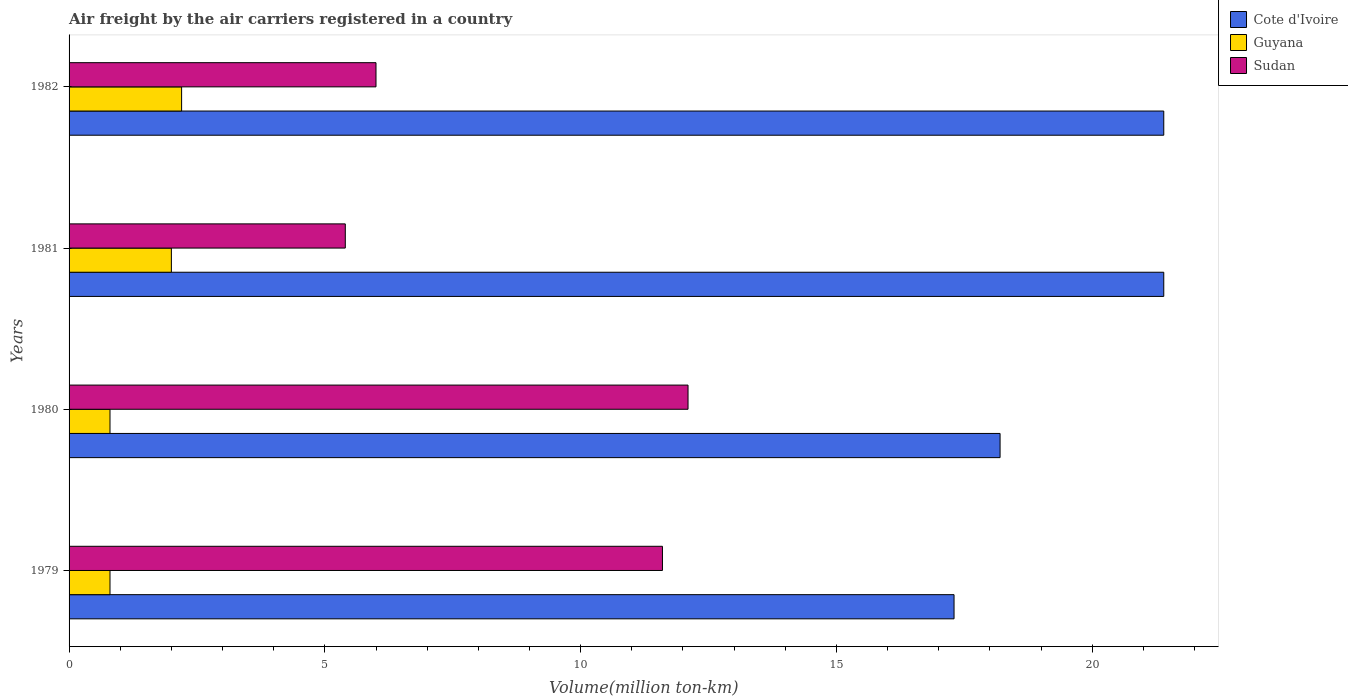How many different coloured bars are there?
Offer a terse response. 3. How many groups of bars are there?
Ensure brevity in your answer.  4. Are the number of bars per tick equal to the number of legend labels?
Offer a terse response. Yes. Are the number of bars on each tick of the Y-axis equal?
Your response must be concise. Yes. How many bars are there on the 3rd tick from the top?
Make the answer very short. 3. What is the label of the 2nd group of bars from the top?
Offer a very short reply. 1981. In how many cases, is the number of bars for a given year not equal to the number of legend labels?
Keep it short and to the point. 0. What is the volume of the air carriers in Guyana in 1979?
Provide a short and direct response. 0.8. Across all years, what is the maximum volume of the air carriers in Cote d'Ivoire?
Make the answer very short. 21.4. Across all years, what is the minimum volume of the air carriers in Guyana?
Provide a succinct answer. 0.8. In which year was the volume of the air carriers in Guyana maximum?
Offer a very short reply. 1982. In which year was the volume of the air carriers in Cote d'Ivoire minimum?
Ensure brevity in your answer.  1979. What is the total volume of the air carriers in Cote d'Ivoire in the graph?
Provide a short and direct response. 78.3. What is the difference between the volume of the air carriers in Sudan in 1979 and that in 1981?
Keep it short and to the point. 6.2. What is the difference between the volume of the air carriers in Guyana in 1981 and the volume of the air carriers in Sudan in 1982?
Keep it short and to the point. -4. What is the average volume of the air carriers in Cote d'Ivoire per year?
Your answer should be very brief. 19.57. In the year 1980, what is the difference between the volume of the air carriers in Sudan and volume of the air carriers in Guyana?
Ensure brevity in your answer.  11.3. In how many years, is the volume of the air carriers in Guyana greater than 7 million ton-km?
Make the answer very short. 0. What is the ratio of the volume of the air carriers in Sudan in 1980 to that in 1981?
Make the answer very short. 2.24. Is the volume of the air carriers in Guyana in 1980 less than that in 1982?
Your response must be concise. Yes. Is the difference between the volume of the air carriers in Sudan in 1979 and 1982 greater than the difference between the volume of the air carriers in Guyana in 1979 and 1982?
Offer a very short reply. Yes. What is the difference between the highest and the lowest volume of the air carriers in Cote d'Ivoire?
Ensure brevity in your answer.  4.1. In how many years, is the volume of the air carriers in Sudan greater than the average volume of the air carriers in Sudan taken over all years?
Provide a short and direct response. 2. What does the 3rd bar from the top in 1981 represents?
Give a very brief answer. Cote d'Ivoire. What does the 1st bar from the bottom in 1980 represents?
Ensure brevity in your answer.  Cote d'Ivoire. Is it the case that in every year, the sum of the volume of the air carriers in Cote d'Ivoire and volume of the air carriers in Guyana is greater than the volume of the air carriers in Sudan?
Offer a very short reply. Yes. How many bars are there?
Your answer should be very brief. 12. Are all the bars in the graph horizontal?
Your response must be concise. Yes. Are the values on the major ticks of X-axis written in scientific E-notation?
Offer a terse response. No. Does the graph contain grids?
Offer a very short reply. No. Where does the legend appear in the graph?
Your answer should be very brief. Top right. How are the legend labels stacked?
Keep it short and to the point. Vertical. What is the title of the graph?
Provide a succinct answer. Air freight by the air carriers registered in a country. What is the label or title of the X-axis?
Your answer should be very brief. Volume(million ton-km). What is the Volume(million ton-km) in Cote d'Ivoire in 1979?
Make the answer very short. 17.3. What is the Volume(million ton-km) in Guyana in 1979?
Offer a very short reply. 0.8. What is the Volume(million ton-km) in Sudan in 1979?
Provide a succinct answer. 11.6. What is the Volume(million ton-km) in Cote d'Ivoire in 1980?
Your response must be concise. 18.2. What is the Volume(million ton-km) in Guyana in 1980?
Make the answer very short. 0.8. What is the Volume(million ton-km) of Sudan in 1980?
Ensure brevity in your answer.  12.1. What is the Volume(million ton-km) of Cote d'Ivoire in 1981?
Offer a terse response. 21.4. What is the Volume(million ton-km) of Guyana in 1981?
Make the answer very short. 2. What is the Volume(million ton-km) in Sudan in 1981?
Your answer should be very brief. 5.4. What is the Volume(million ton-km) in Cote d'Ivoire in 1982?
Keep it short and to the point. 21.4. What is the Volume(million ton-km) of Guyana in 1982?
Offer a very short reply. 2.2. What is the Volume(million ton-km) of Sudan in 1982?
Make the answer very short. 6. Across all years, what is the maximum Volume(million ton-km) of Cote d'Ivoire?
Keep it short and to the point. 21.4. Across all years, what is the maximum Volume(million ton-km) in Guyana?
Provide a short and direct response. 2.2. Across all years, what is the maximum Volume(million ton-km) in Sudan?
Make the answer very short. 12.1. Across all years, what is the minimum Volume(million ton-km) in Cote d'Ivoire?
Your answer should be compact. 17.3. Across all years, what is the minimum Volume(million ton-km) of Guyana?
Offer a terse response. 0.8. Across all years, what is the minimum Volume(million ton-km) in Sudan?
Make the answer very short. 5.4. What is the total Volume(million ton-km) of Cote d'Ivoire in the graph?
Make the answer very short. 78.3. What is the total Volume(million ton-km) of Sudan in the graph?
Offer a terse response. 35.1. What is the difference between the Volume(million ton-km) of Guyana in 1979 and that in 1980?
Ensure brevity in your answer.  0. What is the difference between the Volume(million ton-km) of Sudan in 1979 and that in 1981?
Make the answer very short. 6.2. What is the difference between the Volume(million ton-km) in Cote d'Ivoire in 1979 and that in 1982?
Make the answer very short. -4.1. What is the difference between the Volume(million ton-km) in Cote d'Ivoire in 1980 and that in 1981?
Provide a short and direct response. -3.2. What is the difference between the Volume(million ton-km) in Guyana in 1980 and that in 1981?
Make the answer very short. -1.2. What is the difference between the Volume(million ton-km) in Sudan in 1980 and that in 1981?
Your response must be concise. 6.7. What is the difference between the Volume(million ton-km) in Guyana in 1981 and that in 1982?
Your answer should be very brief. -0.2. What is the difference between the Volume(million ton-km) in Sudan in 1981 and that in 1982?
Provide a short and direct response. -0.6. What is the difference between the Volume(million ton-km) in Cote d'Ivoire in 1979 and the Volume(million ton-km) in Guyana in 1980?
Offer a very short reply. 16.5. What is the difference between the Volume(million ton-km) in Cote d'Ivoire in 1979 and the Volume(million ton-km) in Sudan in 1980?
Offer a terse response. 5.2. What is the difference between the Volume(million ton-km) in Guyana in 1979 and the Volume(million ton-km) in Sudan in 1980?
Make the answer very short. -11.3. What is the difference between the Volume(million ton-km) of Guyana in 1979 and the Volume(million ton-km) of Sudan in 1981?
Keep it short and to the point. -4.6. What is the difference between the Volume(million ton-km) in Cote d'Ivoire in 1979 and the Volume(million ton-km) in Sudan in 1982?
Give a very brief answer. 11.3. What is the difference between the Volume(million ton-km) in Cote d'Ivoire in 1980 and the Volume(million ton-km) in Guyana in 1981?
Keep it short and to the point. 16.2. What is the difference between the Volume(million ton-km) of Cote d'Ivoire in 1980 and the Volume(million ton-km) of Sudan in 1981?
Offer a terse response. 12.8. What is the difference between the Volume(million ton-km) in Guyana in 1980 and the Volume(million ton-km) in Sudan in 1982?
Give a very brief answer. -5.2. What is the difference between the Volume(million ton-km) in Guyana in 1981 and the Volume(million ton-km) in Sudan in 1982?
Give a very brief answer. -4. What is the average Volume(million ton-km) of Cote d'Ivoire per year?
Keep it short and to the point. 19.57. What is the average Volume(million ton-km) of Guyana per year?
Keep it short and to the point. 1.45. What is the average Volume(million ton-km) of Sudan per year?
Ensure brevity in your answer.  8.78. In the year 1979, what is the difference between the Volume(million ton-km) of Guyana and Volume(million ton-km) of Sudan?
Your answer should be compact. -10.8. In the year 1980, what is the difference between the Volume(million ton-km) in Cote d'Ivoire and Volume(million ton-km) in Guyana?
Offer a very short reply. 17.4. In the year 1980, what is the difference between the Volume(million ton-km) in Cote d'Ivoire and Volume(million ton-km) in Sudan?
Keep it short and to the point. 6.1. In the year 1980, what is the difference between the Volume(million ton-km) of Guyana and Volume(million ton-km) of Sudan?
Your response must be concise. -11.3. In the year 1981, what is the difference between the Volume(million ton-km) of Cote d'Ivoire and Volume(million ton-km) of Guyana?
Provide a succinct answer. 19.4. In the year 1982, what is the difference between the Volume(million ton-km) in Cote d'Ivoire and Volume(million ton-km) in Guyana?
Your answer should be very brief. 19.2. In the year 1982, what is the difference between the Volume(million ton-km) of Cote d'Ivoire and Volume(million ton-km) of Sudan?
Offer a terse response. 15.4. In the year 1982, what is the difference between the Volume(million ton-km) in Guyana and Volume(million ton-km) in Sudan?
Make the answer very short. -3.8. What is the ratio of the Volume(million ton-km) of Cote d'Ivoire in 1979 to that in 1980?
Ensure brevity in your answer.  0.95. What is the ratio of the Volume(million ton-km) in Sudan in 1979 to that in 1980?
Keep it short and to the point. 0.96. What is the ratio of the Volume(million ton-km) in Cote d'Ivoire in 1979 to that in 1981?
Provide a succinct answer. 0.81. What is the ratio of the Volume(million ton-km) of Sudan in 1979 to that in 1981?
Your answer should be very brief. 2.15. What is the ratio of the Volume(million ton-km) in Cote d'Ivoire in 1979 to that in 1982?
Keep it short and to the point. 0.81. What is the ratio of the Volume(million ton-km) of Guyana in 1979 to that in 1982?
Keep it short and to the point. 0.36. What is the ratio of the Volume(million ton-km) in Sudan in 1979 to that in 1982?
Give a very brief answer. 1.93. What is the ratio of the Volume(million ton-km) of Cote d'Ivoire in 1980 to that in 1981?
Provide a short and direct response. 0.85. What is the ratio of the Volume(million ton-km) in Guyana in 1980 to that in 1981?
Your answer should be very brief. 0.4. What is the ratio of the Volume(million ton-km) of Sudan in 1980 to that in 1981?
Keep it short and to the point. 2.24. What is the ratio of the Volume(million ton-km) in Cote d'Ivoire in 1980 to that in 1982?
Offer a very short reply. 0.85. What is the ratio of the Volume(million ton-km) in Guyana in 1980 to that in 1982?
Your answer should be very brief. 0.36. What is the ratio of the Volume(million ton-km) in Sudan in 1980 to that in 1982?
Your answer should be very brief. 2.02. What is the ratio of the Volume(million ton-km) of Cote d'Ivoire in 1981 to that in 1982?
Offer a terse response. 1. What is the ratio of the Volume(million ton-km) of Guyana in 1981 to that in 1982?
Make the answer very short. 0.91. What is the ratio of the Volume(million ton-km) of Sudan in 1981 to that in 1982?
Offer a terse response. 0.9. What is the difference between the highest and the second highest Volume(million ton-km) of Guyana?
Offer a terse response. 0.2. What is the difference between the highest and the second highest Volume(million ton-km) of Sudan?
Your response must be concise. 0.5. What is the difference between the highest and the lowest Volume(million ton-km) in Guyana?
Your answer should be compact. 1.4. 